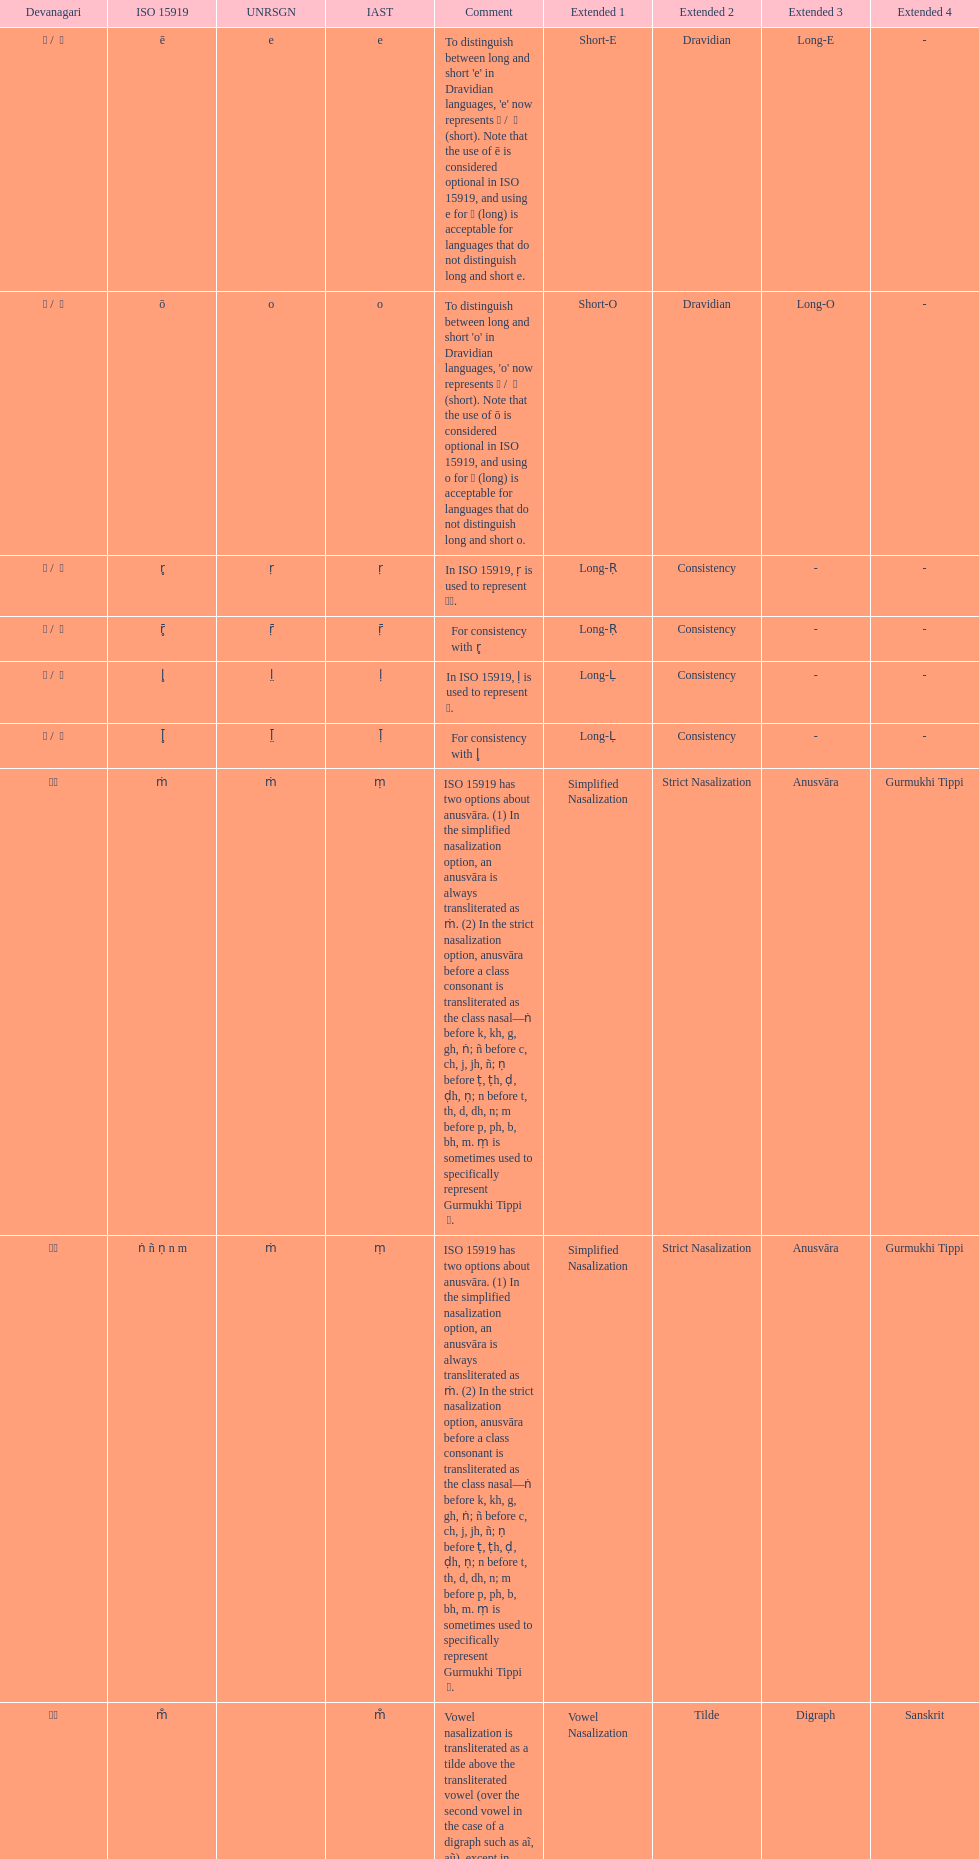What is the cumulative number of translations? 8. 